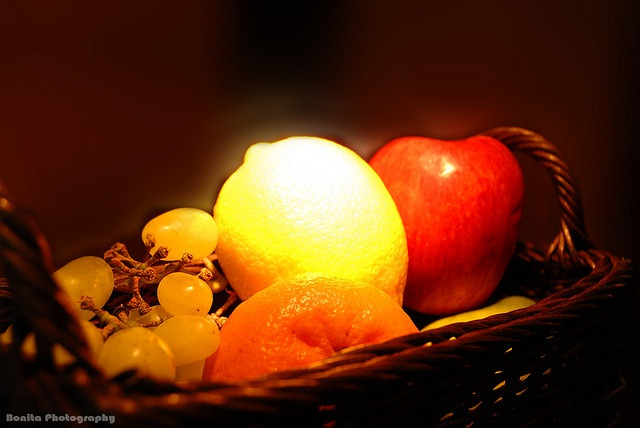Describe the objects in this image and their specific colors. I can see apple in maroon and red tones and orange in maroon, red, orange, and gold tones in this image. 